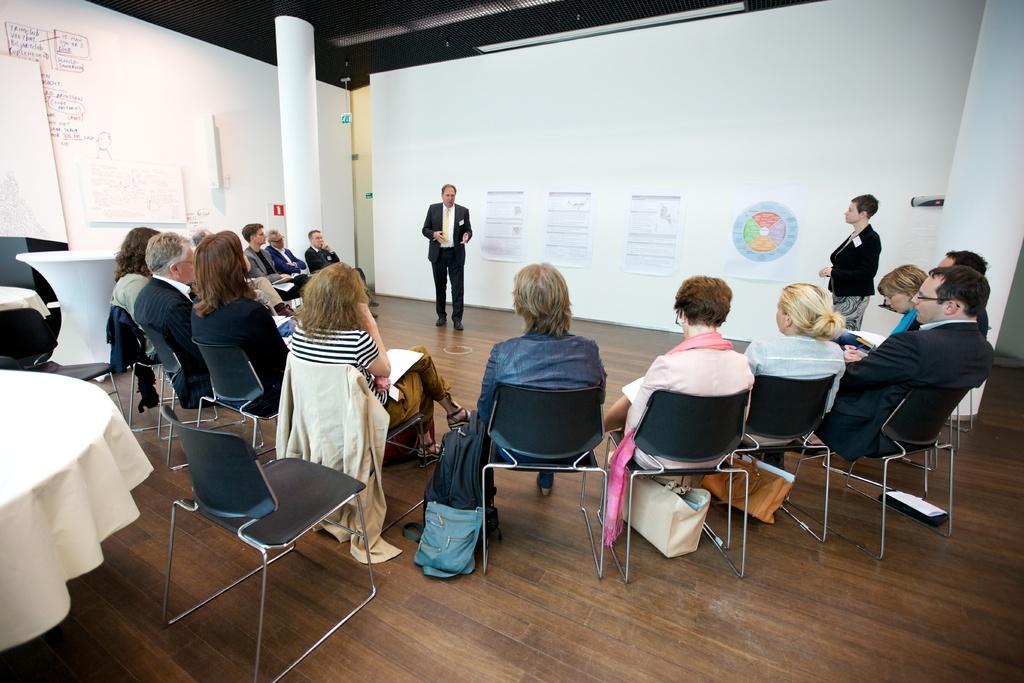How would you summarize this image in a sentence or two? In this picture there are a group of people sitting in a semicircle. There are two people standing and explaining them. In the backdrop there are posters pasted on the wall. 